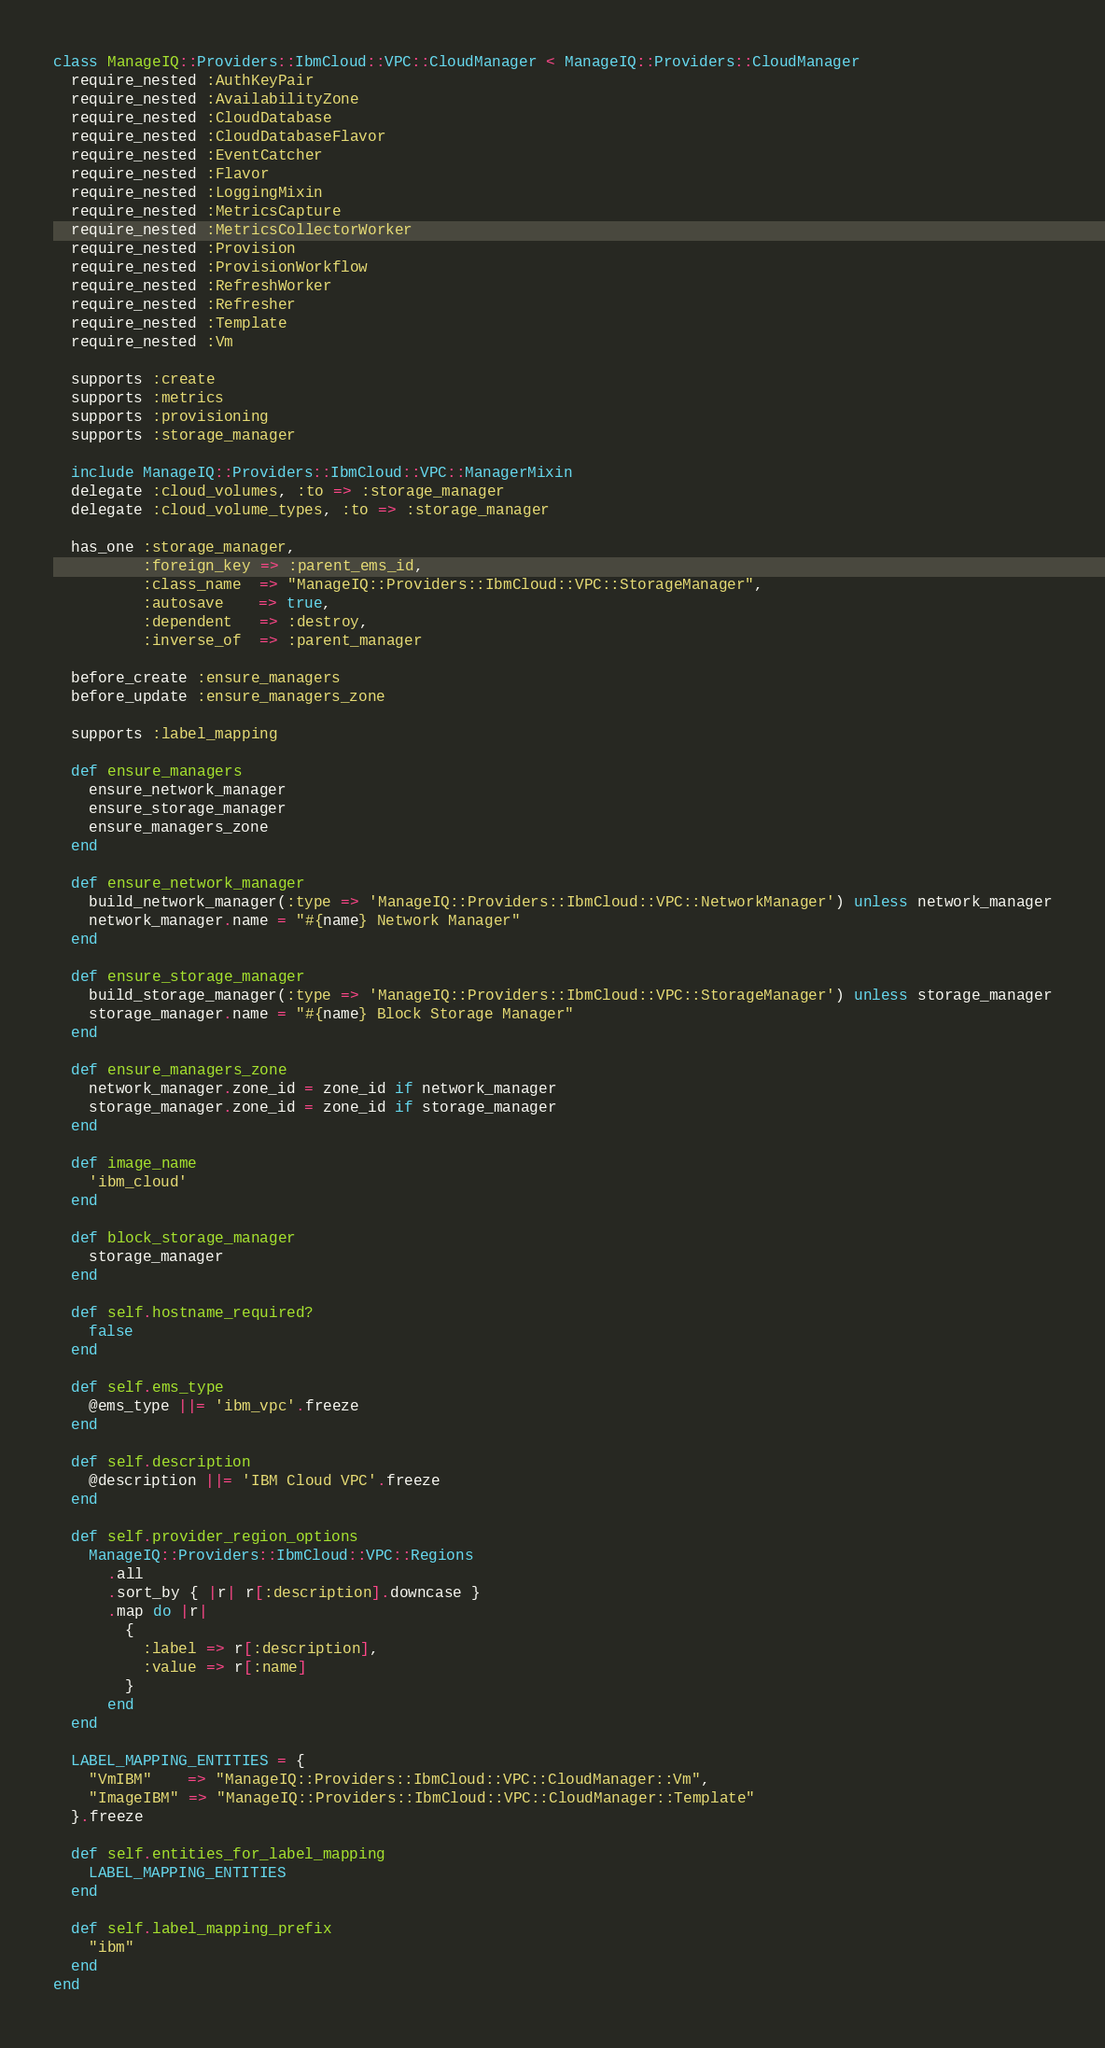Convert code to text. <code><loc_0><loc_0><loc_500><loc_500><_Ruby_>class ManageIQ::Providers::IbmCloud::VPC::CloudManager < ManageIQ::Providers::CloudManager
  require_nested :AuthKeyPair
  require_nested :AvailabilityZone
  require_nested :CloudDatabase
  require_nested :CloudDatabaseFlavor
  require_nested :EventCatcher
  require_nested :Flavor
  require_nested :LoggingMixin
  require_nested :MetricsCapture
  require_nested :MetricsCollectorWorker
  require_nested :Provision
  require_nested :ProvisionWorkflow
  require_nested :RefreshWorker
  require_nested :Refresher
  require_nested :Template
  require_nested :Vm

  supports :create
  supports :metrics
  supports :provisioning
  supports :storage_manager

  include ManageIQ::Providers::IbmCloud::VPC::ManagerMixin
  delegate :cloud_volumes, :to => :storage_manager
  delegate :cloud_volume_types, :to => :storage_manager

  has_one :storage_manager,
          :foreign_key => :parent_ems_id,
          :class_name  => "ManageIQ::Providers::IbmCloud::VPC::StorageManager",
          :autosave    => true,
          :dependent   => :destroy,
          :inverse_of  => :parent_manager

  before_create :ensure_managers
  before_update :ensure_managers_zone

  supports :label_mapping

  def ensure_managers
    ensure_network_manager
    ensure_storage_manager
    ensure_managers_zone
  end

  def ensure_network_manager
    build_network_manager(:type => 'ManageIQ::Providers::IbmCloud::VPC::NetworkManager') unless network_manager
    network_manager.name = "#{name} Network Manager"
  end

  def ensure_storage_manager
    build_storage_manager(:type => 'ManageIQ::Providers::IbmCloud::VPC::StorageManager') unless storage_manager
    storage_manager.name = "#{name} Block Storage Manager"
  end

  def ensure_managers_zone
    network_manager.zone_id = zone_id if network_manager
    storage_manager.zone_id = zone_id if storage_manager
  end

  def image_name
    'ibm_cloud'
  end

  def block_storage_manager
    storage_manager
  end

  def self.hostname_required?
    false
  end

  def self.ems_type
    @ems_type ||= 'ibm_vpc'.freeze
  end

  def self.description
    @description ||= 'IBM Cloud VPC'.freeze
  end

  def self.provider_region_options
    ManageIQ::Providers::IbmCloud::VPC::Regions
      .all
      .sort_by { |r| r[:description].downcase }
      .map do |r|
        {
          :label => r[:description],
          :value => r[:name]
        }
      end
  end

  LABEL_MAPPING_ENTITIES = {
    "VmIBM"    => "ManageIQ::Providers::IbmCloud::VPC::CloudManager::Vm",
    "ImageIBM" => "ManageIQ::Providers::IbmCloud::VPC::CloudManager::Template"
  }.freeze

  def self.entities_for_label_mapping
    LABEL_MAPPING_ENTITIES
  end

  def self.label_mapping_prefix
    "ibm"
  end
end
</code> 